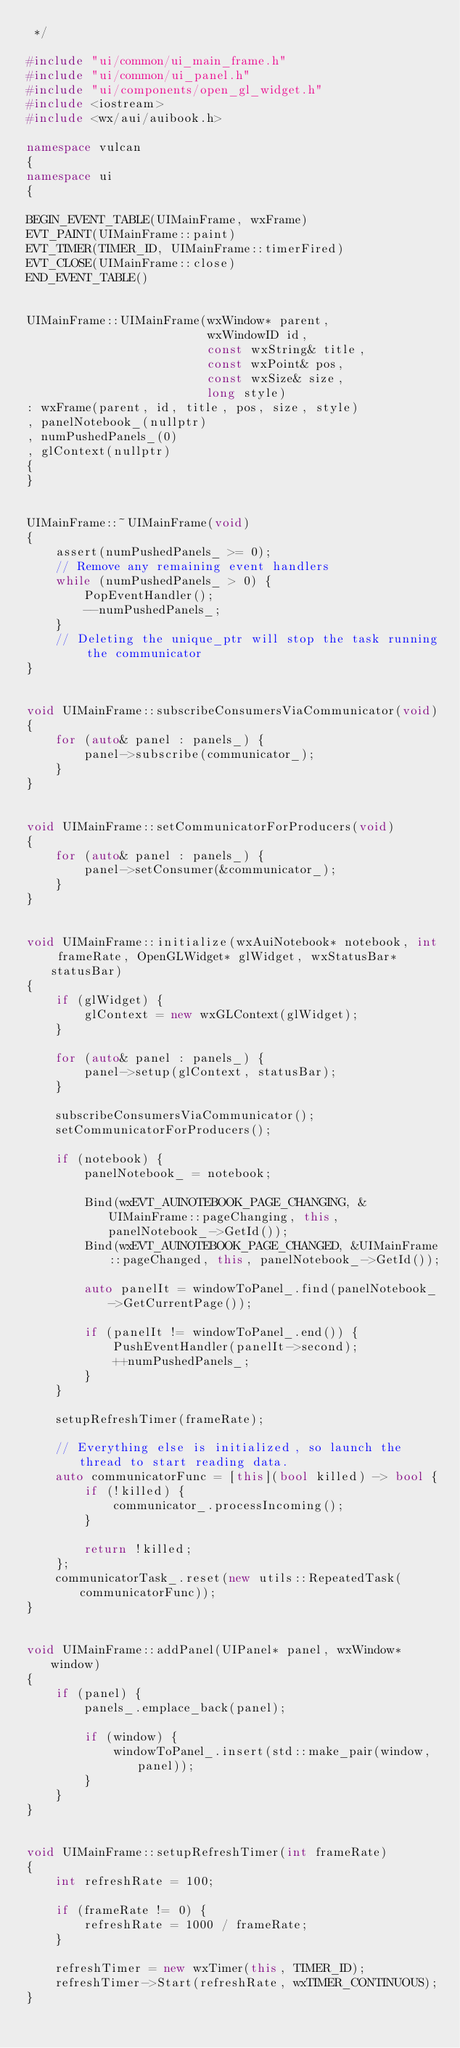<code> <loc_0><loc_0><loc_500><loc_500><_C++_> */

#include "ui/common/ui_main_frame.h"
#include "ui/common/ui_panel.h"
#include "ui/components/open_gl_widget.h"
#include <iostream>
#include <wx/aui/auibook.h>

namespace vulcan
{
namespace ui
{

BEGIN_EVENT_TABLE(UIMainFrame, wxFrame)
EVT_PAINT(UIMainFrame::paint)
EVT_TIMER(TIMER_ID, UIMainFrame::timerFired)
EVT_CLOSE(UIMainFrame::close)
END_EVENT_TABLE()


UIMainFrame::UIMainFrame(wxWindow* parent,
                         wxWindowID id,
                         const wxString& title,
                         const wxPoint& pos,
                         const wxSize& size,
                         long style)
: wxFrame(parent, id, title, pos, size, style)
, panelNotebook_(nullptr)
, numPushedPanels_(0)
, glContext(nullptr)
{
}


UIMainFrame::~UIMainFrame(void)
{
    assert(numPushedPanels_ >= 0);
    // Remove any remaining event handlers
    while (numPushedPanels_ > 0) {
        PopEventHandler();
        --numPushedPanels_;
    }
    // Deleting the unique_ptr will stop the task running the communicator
}


void UIMainFrame::subscribeConsumersViaCommunicator(void)
{
    for (auto& panel : panels_) {
        panel->subscribe(communicator_);
    }
}


void UIMainFrame::setCommunicatorForProducers(void)
{
    for (auto& panel : panels_) {
        panel->setConsumer(&communicator_);
    }
}


void UIMainFrame::initialize(wxAuiNotebook* notebook, int frameRate, OpenGLWidget* glWidget, wxStatusBar* statusBar)
{
    if (glWidget) {
        glContext = new wxGLContext(glWidget);
    }

    for (auto& panel : panels_) {
        panel->setup(glContext, statusBar);
    }

    subscribeConsumersViaCommunicator();
    setCommunicatorForProducers();

    if (notebook) {
        panelNotebook_ = notebook;

        Bind(wxEVT_AUINOTEBOOK_PAGE_CHANGING, &UIMainFrame::pageChanging, this, panelNotebook_->GetId());
        Bind(wxEVT_AUINOTEBOOK_PAGE_CHANGED, &UIMainFrame::pageChanged, this, panelNotebook_->GetId());

        auto panelIt = windowToPanel_.find(panelNotebook_->GetCurrentPage());

        if (panelIt != windowToPanel_.end()) {
            PushEventHandler(panelIt->second);
            ++numPushedPanels_;
        }
    }

    setupRefreshTimer(frameRate);

    // Everything else is initialized, so launch the thread to start reading data.
    auto communicatorFunc = [this](bool killed) -> bool {
        if (!killed) {
            communicator_.processIncoming();
        }

        return !killed;
    };
    communicatorTask_.reset(new utils::RepeatedTask(communicatorFunc));
}


void UIMainFrame::addPanel(UIPanel* panel, wxWindow* window)
{
    if (panel) {
        panels_.emplace_back(panel);

        if (window) {
            windowToPanel_.insert(std::make_pair(window, panel));
        }
    }
}


void UIMainFrame::setupRefreshTimer(int frameRate)
{
    int refreshRate = 100;

    if (frameRate != 0) {
        refreshRate = 1000 / frameRate;
    }

    refreshTimer = new wxTimer(this, TIMER_ID);
    refreshTimer->Start(refreshRate, wxTIMER_CONTINUOUS);
}

</code> 